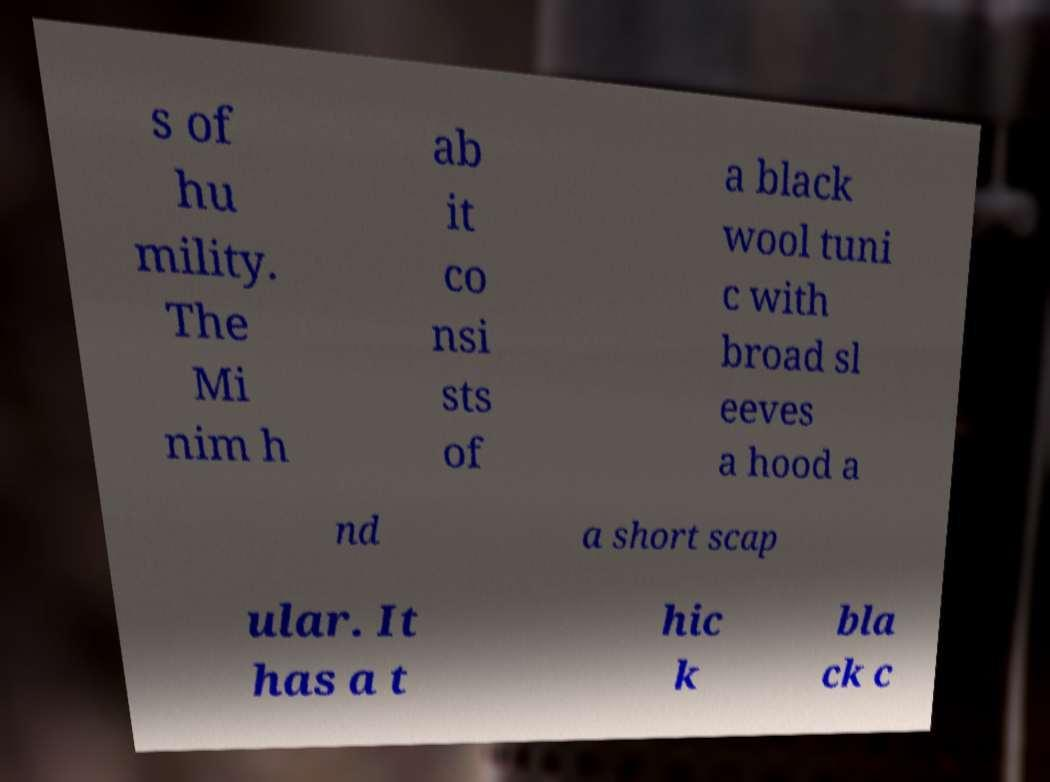Please read and relay the text visible in this image. What does it say? s of hu mility. The Mi nim h ab it co nsi sts of a black wool tuni c with broad sl eeves a hood a nd a short scap ular. It has a t hic k bla ck c 